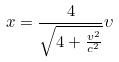<formula> <loc_0><loc_0><loc_500><loc_500>x = \frac { 4 } { \sqrt { 4 + \frac { v ^ { 2 } } { c ^ { 2 } } } } \upsilon</formula> 